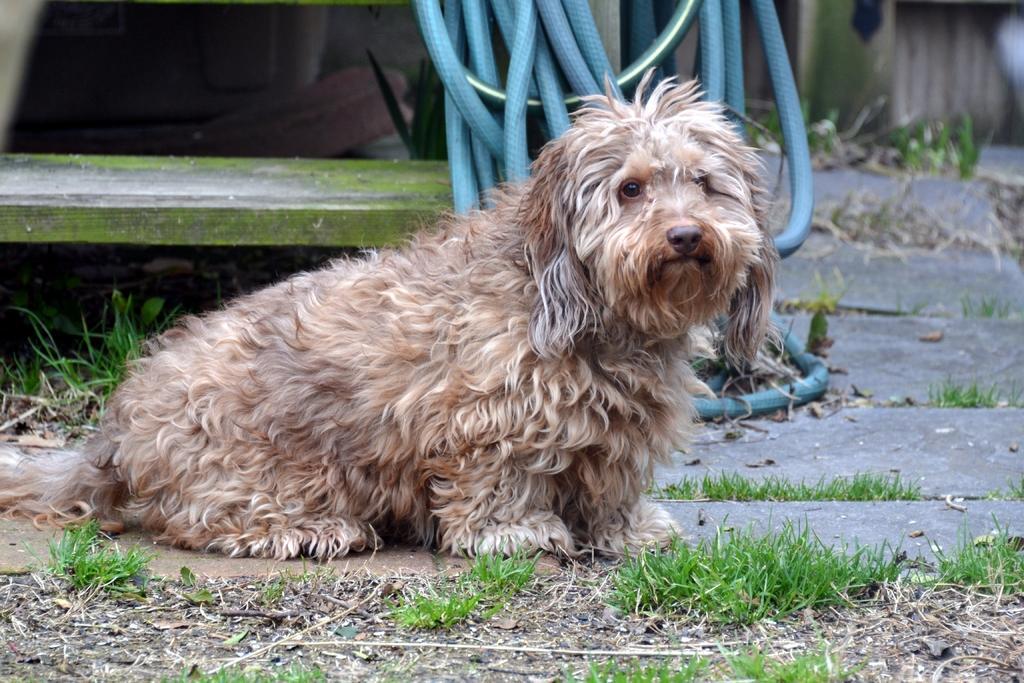In one or two sentences, can you explain what this image depicts? We can see dog on the surface and grass. We can see pipe and wooden bench. 